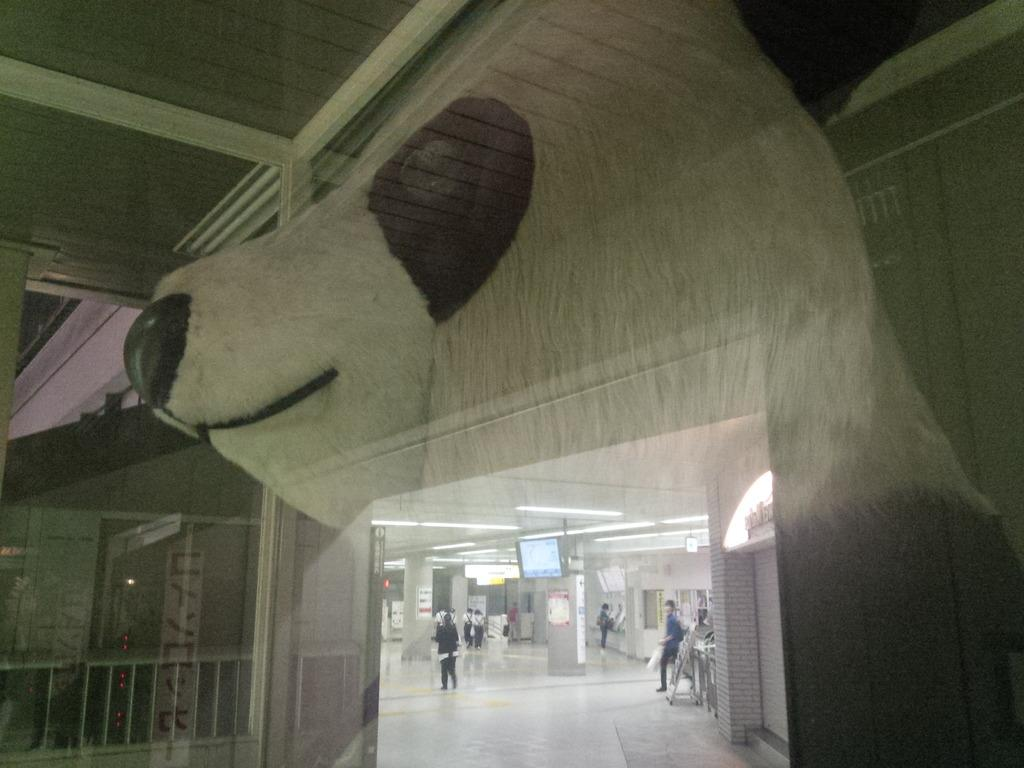Who or what can be seen in the image? There are people in the image. What architectural features are present in the image? There are pillars in the image. What electronic device is visible in the image? There is a TV in the image. What structural elements can be observed in the image? The walls and the rooftop are visible in the image. What type of barrier is present in the image? There is a fence in the image. Is there any reflection visible in the image? Yes, there is a reflection of a teddy bear in the image. How many quarters can be seen in the image? There are no quarters visible in the image. What type of bag is being carried by the people in the image? The provided facts do not mention any bags being carried by the people in the image. Are there any ants crawling on the TV in the image? There are no ants visible in the image, and they are not mentioned in the provided facts. 